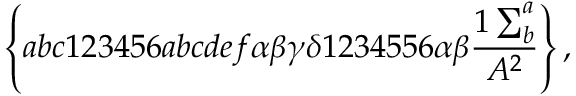Convert formula to latex. <formula><loc_0><loc_0><loc_500><loc_500>\left \{ a b c 1 2 3 4 5 6 a b c d e f \alpha \beta \gamma \delta 1 2 3 4 5 5 6 \alpha \beta \frac { 1 \sum _ { b } ^ { a } } { A ^ { 2 } } \right \} ,</formula> 